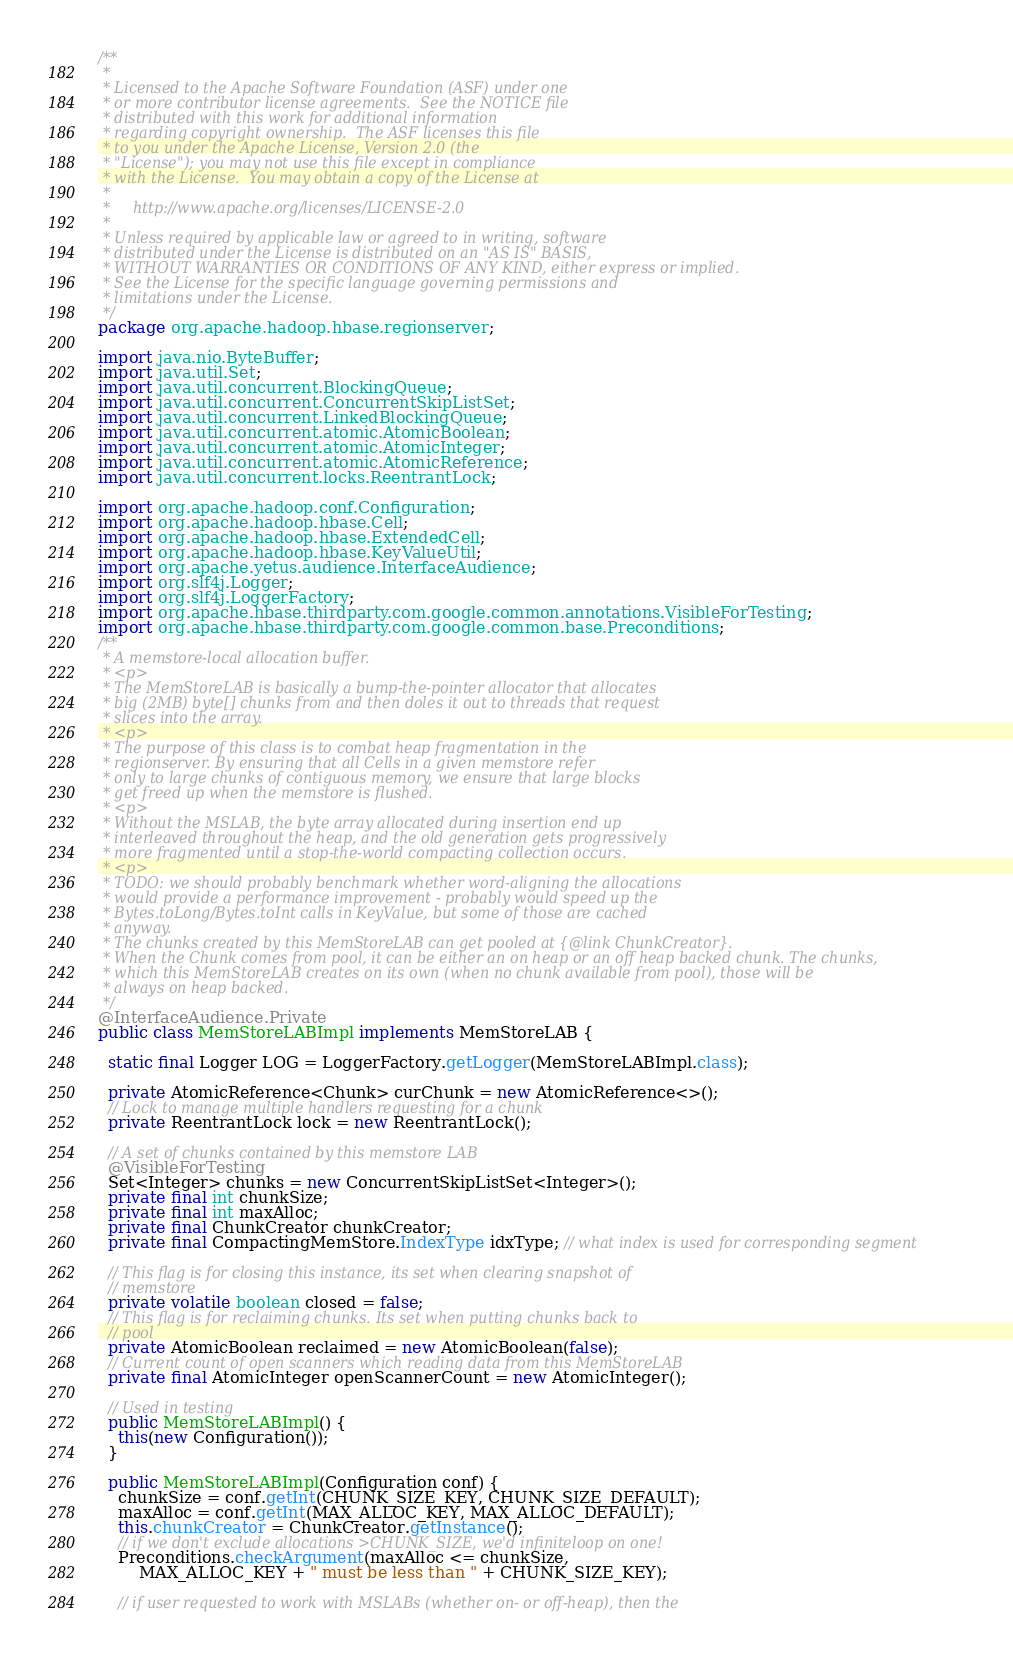Convert code to text. <code><loc_0><loc_0><loc_500><loc_500><_Java_>/**
 *
 * Licensed to the Apache Software Foundation (ASF) under one
 * or more contributor license agreements.  See the NOTICE file
 * distributed with this work for additional information
 * regarding copyright ownership.  The ASF licenses this file
 * to you under the Apache License, Version 2.0 (the
 * "License"); you may not use this file except in compliance
 * with the License.  You may obtain a copy of the License at
 *
 *     http://www.apache.org/licenses/LICENSE-2.0
 *
 * Unless required by applicable law or agreed to in writing, software
 * distributed under the License is distributed on an "AS IS" BASIS,
 * WITHOUT WARRANTIES OR CONDITIONS OF ANY KIND, either express or implied.
 * See the License for the specific language governing permissions and
 * limitations under the License.
 */
package org.apache.hadoop.hbase.regionserver;

import java.nio.ByteBuffer;
import java.util.Set;
import java.util.concurrent.BlockingQueue;
import java.util.concurrent.ConcurrentSkipListSet;
import java.util.concurrent.LinkedBlockingQueue;
import java.util.concurrent.atomic.AtomicBoolean;
import java.util.concurrent.atomic.AtomicInteger;
import java.util.concurrent.atomic.AtomicReference;
import java.util.concurrent.locks.ReentrantLock;

import org.apache.hadoop.conf.Configuration;
import org.apache.hadoop.hbase.Cell;
import org.apache.hadoop.hbase.ExtendedCell;
import org.apache.hadoop.hbase.KeyValueUtil;
import org.apache.yetus.audience.InterfaceAudience;
import org.slf4j.Logger;
import org.slf4j.LoggerFactory;
import org.apache.hbase.thirdparty.com.google.common.annotations.VisibleForTesting;
import org.apache.hbase.thirdparty.com.google.common.base.Preconditions;
/**
 * A memstore-local allocation buffer.
 * <p>
 * The MemStoreLAB is basically a bump-the-pointer allocator that allocates
 * big (2MB) byte[] chunks from and then doles it out to threads that request
 * slices into the array.
 * <p>
 * The purpose of this class is to combat heap fragmentation in the
 * regionserver. By ensuring that all Cells in a given memstore refer
 * only to large chunks of contiguous memory, we ensure that large blocks
 * get freed up when the memstore is flushed.
 * <p>
 * Without the MSLAB, the byte array allocated during insertion end up
 * interleaved throughout the heap, and the old generation gets progressively
 * more fragmented until a stop-the-world compacting collection occurs.
 * <p>
 * TODO: we should probably benchmark whether word-aligning the allocations
 * would provide a performance improvement - probably would speed up the
 * Bytes.toLong/Bytes.toInt calls in KeyValue, but some of those are cached
 * anyway.
 * The chunks created by this MemStoreLAB can get pooled at {@link ChunkCreator}.
 * When the Chunk comes from pool, it can be either an on heap or an off heap backed chunk. The chunks,
 * which this MemStoreLAB creates on its own (when no chunk available from pool), those will be
 * always on heap backed.
 */
@InterfaceAudience.Private
public class MemStoreLABImpl implements MemStoreLAB {

  static final Logger LOG = LoggerFactory.getLogger(MemStoreLABImpl.class);

  private AtomicReference<Chunk> curChunk = new AtomicReference<>();
  // Lock to manage multiple handlers requesting for a chunk
  private ReentrantLock lock = new ReentrantLock();

  // A set of chunks contained by this memstore LAB
  @VisibleForTesting
  Set<Integer> chunks = new ConcurrentSkipListSet<Integer>();
  private final int chunkSize;
  private final int maxAlloc;
  private final ChunkCreator chunkCreator;
  private final CompactingMemStore.IndexType idxType; // what index is used for corresponding segment

  // This flag is for closing this instance, its set when clearing snapshot of
  // memstore
  private volatile boolean closed = false;
  // This flag is for reclaiming chunks. Its set when putting chunks back to
  // pool
  private AtomicBoolean reclaimed = new AtomicBoolean(false);
  // Current count of open scanners which reading data from this MemStoreLAB
  private final AtomicInteger openScannerCount = new AtomicInteger();

  // Used in testing
  public MemStoreLABImpl() {
    this(new Configuration());
  }

  public MemStoreLABImpl(Configuration conf) {
    chunkSize = conf.getInt(CHUNK_SIZE_KEY, CHUNK_SIZE_DEFAULT);
    maxAlloc = conf.getInt(MAX_ALLOC_KEY, MAX_ALLOC_DEFAULT);
    this.chunkCreator = ChunkCreator.getInstance();
    // if we don't exclude allocations >CHUNK_SIZE, we'd infiniteloop on one!
    Preconditions.checkArgument(maxAlloc <= chunkSize,
        MAX_ALLOC_KEY + " must be less than " + CHUNK_SIZE_KEY);

    // if user requested to work with MSLABs (whether on- or off-heap), then the</code> 